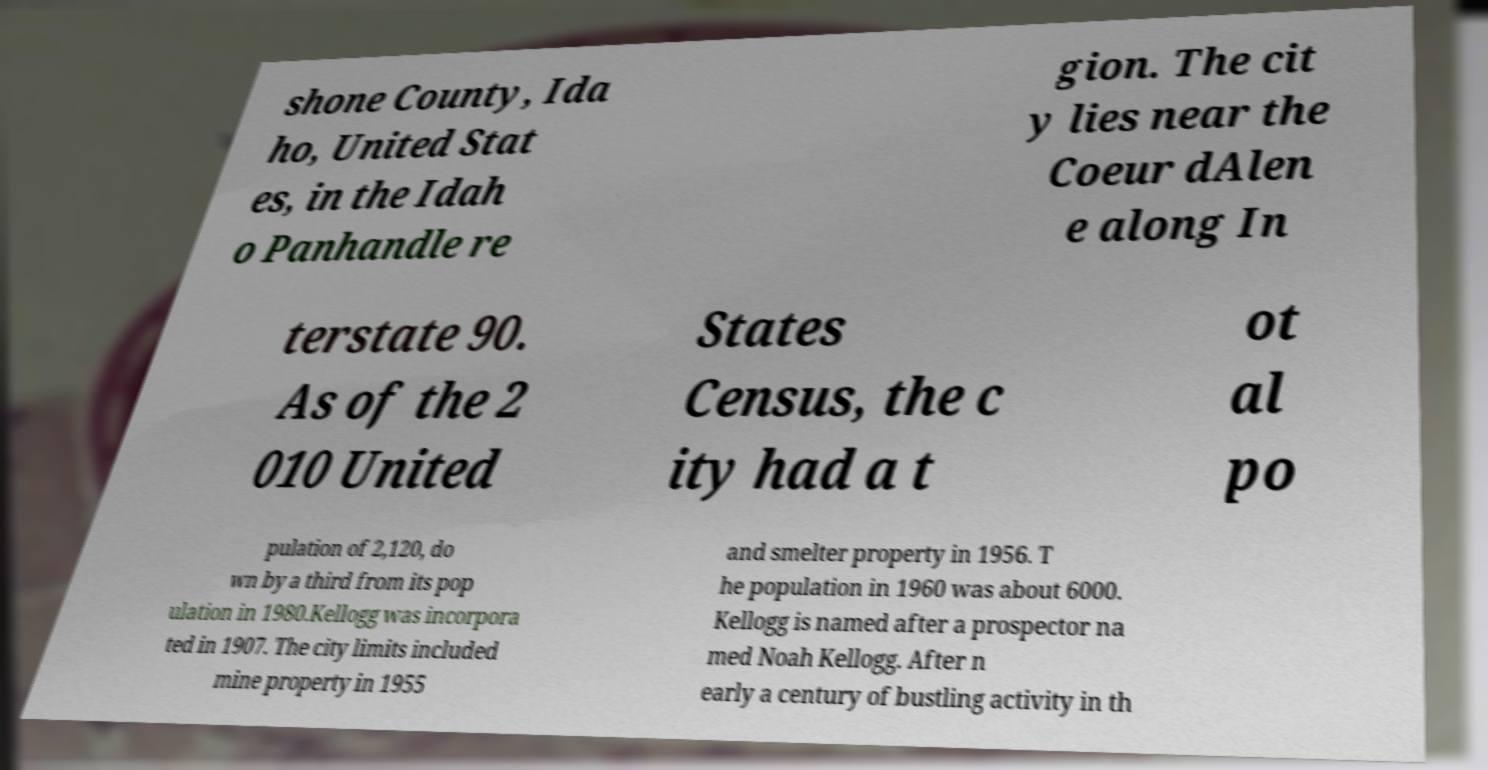What messages or text are displayed in this image? I need them in a readable, typed format. shone County, Ida ho, United Stat es, in the Idah o Panhandle re gion. The cit y lies near the Coeur dAlen e along In terstate 90. As of the 2 010 United States Census, the c ity had a t ot al po pulation of 2,120, do wn by a third from its pop ulation in 1980.Kellogg was incorpora ted in 1907. The city limits included mine property in 1955 and smelter property in 1956. T he population in 1960 was about 6000. Kellogg is named after a prospector na med Noah Kellogg. After n early a century of bustling activity in th 